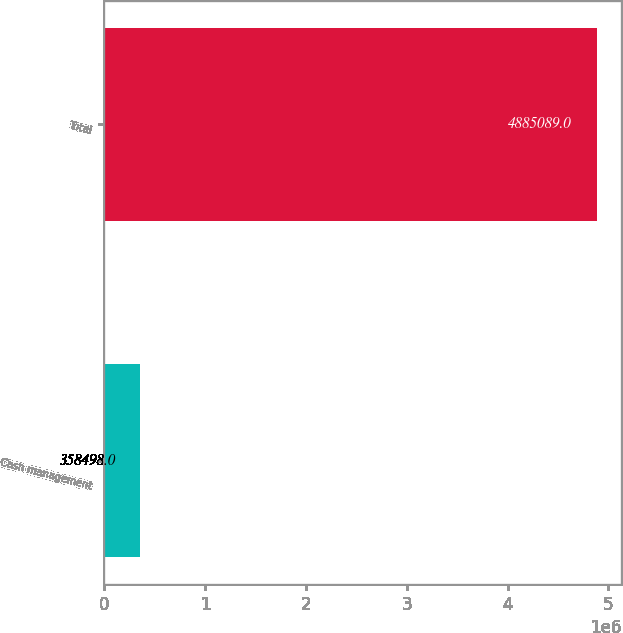Convert chart. <chart><loc_0><loc_0><loc_500><loc_500><bar_chart><fcel>Cash management<fcel>Total<nl><fcel>358498<fcel>4.88509e+06<nl></chart> 